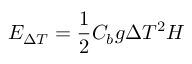<formula> <loc_0><loc_0><loc_500><loc_500>E _ { \Delta T } = \frac { 1 } { 2 } C _ { b } g \Delta T ^ { 2 } H</formula> 